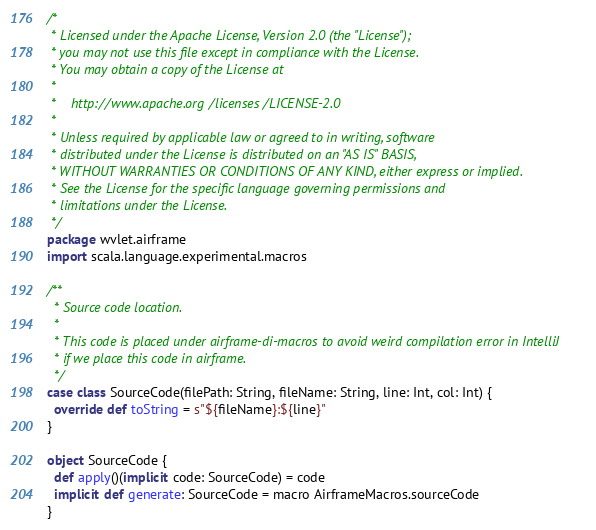Convert code to text. <code><loc_0><loc_0><loc_500><loc_500><_Scala_>/*
 * Licensed under the Apache License, Version 2.0 (the "License");
 * you may not use this file except in compliance with the License.
 * You may obtain a copy of the License at
 *
 *    http://www.apache.org/licenses/LICENSE-2.0
 *
 * Unless required by applicable law or agreed to in writing, software
 * distributed under the License is distributed on an "AS IS" BASIS,
 * WITHOUT WARRANTIES OR CONDITIONS OF ANY KIND, either express or implied.
 * See the License for the specific language governing permissions and
 * limitations under the License.
 */
package wvlet.airframe
import scala.language.experimental.macros

/**
  * Source code location.
  *
  * This code is placed under airframe-di-macros to avoid weird compilation error in IntelliJ
  * if we place this code in airframe.
  */
case class SourceCode(filePath: String, fileName: String, line: Int, col: Int) {
  override def toString = s"${fileName}:${line}"
}

object SourceCode {
  def apply()(implicit code: SourceCode) = code
  implicit def generate: SourceCode = macro AirframeMacros.sourceCode
}
</code> 